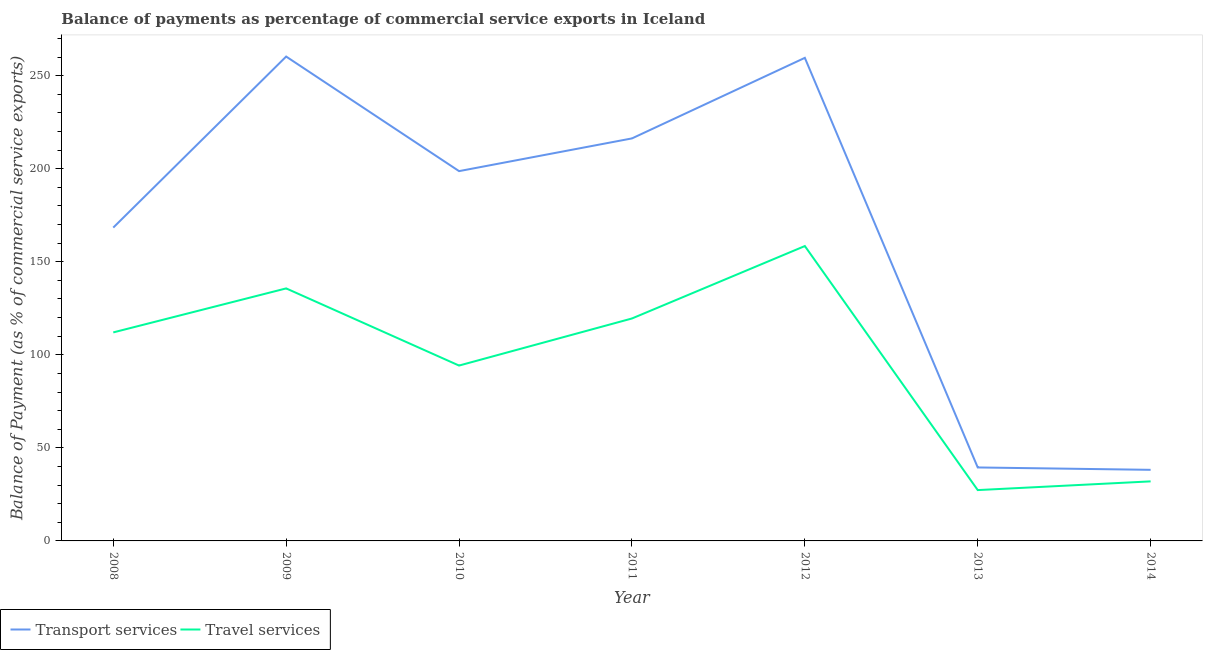What is the balance of payments of transport services in 2008?
Make the answer very short. 168.36. Across all years, what is the maximum balance of payments of travel services?
Ensure brevity in your answer.  158.45. Across all years, what is the minimum balance of payments of travel services?
Offer a terse response. 27.32. What is the total balance of payments of transport services in the graph?
Offer a very short reply. 1180.86. What is the difference between the balance of payments of travel services in 2008 and that in 2009?
Offer a very short reply. -23.64. What is the difference between the balance of payments of transport services in 2010 and the balance of payments of travel services in 2009?
Provide a short and direct response. 63.02. What is the average balance of payments of travel services per year?
Provide a succinct answer. 97.03. In the year 2013, what is the difference between the balance of payments of travel services and balance of payments of transport services?
Provide a succinct answer. -12.16. In how many years, is the balance of payments of travel services greater than 10 %?
Provide a succinct answer. 7. What is the ratio of the balance of payments of travel services in 2009 to that in 2011?
Provide a succinct answer. 1.14. Is the difference between the balance of payments of travel services in 2009 and 2013 greater than the difference between the balance of payments of transport services in 2009 and 2013?
Offer a very short reply. No. What is the difference between the highest and the second highest balance of payments of transport services?
Offer a terse response. 0.7. What is the difference between the highest and the lowest balance of payments of travel services?
Give a very brief answer. 131.13. How many lines are there?
Your response must be concise. 2. How many years are there in the graph?
Provide a succinct answer. 7. What is the difference between two consecutive major ticks on the Y-axis?
Make the answer very short. 50. Does the graph contain any zero values?
Ensure brevity in your answer.  No. Does the graph contain grids?
Your answer should be very brief. No. Where does the legend appear in the graph?
Offer a very short reply. Bottom left. How many legend labels are there?
Keep it short and to the point. 2. What is the title of the graph?
Your answer should be compact. Balance of payments as percentage of commercial service exports in Iceland. Does "IMF nonconcessional" appear as one of the legend labels in the graph?
Ensure brevity in your answer.  No. What is the label or title of the Y-axis?
Provide a succinct answer. Balance of Payment (as % of commercial service exports). What is the Balance of Payment (as % of commercial service exports) in Transport services in 2008?
Offer a terse response. 168.36. What is the Balance of Payment (as % of commercial service exports) in Travel services in 2008?
Your answer should be very brief. 112.04. What is the Balance of Payment (as % of commercial service exports) of Transport services in 2009?
Offer a very short reply. 260.27. What is the Balance of Payment (as % of commercial service exports) in Travel services in 2009?
Offer a very short reply. 135.69. What is the Balance of Payment (as % of commercial service exports) in Transport services in 2010?
Offer a terse response. 198.71. What is the Balance of Payment (as % of commercial service exports) of Travel services in 2010?
Give a very brief answer. 94.23. What is the Balance of Payment (as % of commercial service exports) in Transport services in 2011?
Offer a very short reply. 216.28. What is the Balance of Payment (as % of commercial service exports) of Travel services in 2011?
Provide a succinct answer. 119.52. What is the Balance of Payment (as % of commercial service exports) in Transport services in 2012?
Provide a short and direct response. 259.57. What is the Balance of Payment (as % of commercial service exports) of Travel services in 2012?
Keep it short and to the point. 158.45. What is the Balance of Payment (as % of commercial service exports) in Transport services in 2013?
Your answer should be very brief. 39.47. What is the Balance of Payment (as % of commercial service exports) of Travel services in 2013?
Give a very brief answer. 27.32. What is the Balance of Payment (as % of commercial service exports) in Transport services in 2014?
Offer a terse response. 38.2. What is the Balance of Payment (as % of commercial service exports) of Travel services in 2014?
Offer a terse response. 32. Across all years, what is the maximum Balance of Payment (as % of commercial service exports) of Transport services?
Your answer should be compact. 260.27. Across all years, what is the maximum Balance of Payment (as % of commercial service exports) of Travel services?
Keep it short and to the point. 158.45. Across all years, what is the minimum Balance of Payment (as % of commercial service exports) in Transport services?
Your answer should be compact. 38.2. Across all years, what is the minimum Balance of Payment (as % of commercial service exports) of Travel services?
Offer a terse response. 27.32. What is the total Balance of Payment (as % of commercial service exports) of Transport services in the graph?
Your answer should be compact. 1180.86. What is the total Balance of Payment (as % of commercial service exports) in Travel services in the graph?
Keep it short and to the point. 679.24. What is the difference between the Balance of Payment (as % of commercial service exports) of Transport services in 2008 and that in 2009?
Ensure brevity in your answer.  -91.91. What is the difference between the Balance of Payment (as % of commercial service exports) in Travel services in 2008 and that in 2009?
Give a very brief answer. -23.64. What is the difference between the Balance of Payment (as % of commercial service exports) of Transport services in 2008 and that in 2010?
Make the answer very short. -30.35. What is the difference between the Balance of Payment (as % of commercial service exports) of Travel services in 2008 and that in 2010?
Provide a short and direct response. 17.82. What is the difference between the Balance of Payment (as % of commercial service exports) in Transport services in 2008 and that in 2011?
Ensure brevity in your answer.  -47.92. What is the difference between the Balance of Payment (as % of commercial service exports) in Travel services in 2008 and that in 2011?
Provide a short and direct response. -7.48. What is the difference between the Balance of Payment (as % of commercial service exports) of Transport services in 2008 and that in 2012?
Give a very brief answer. -91.21. What is the difference between the Balance of Payment (as % of commercial service exports) in Travel services in 2008 and that in 2012?
Ensure brevity in your answer.  -46.4. What is the difference between the Balance of Payment (as % of commercial service exports) of Transport services in 2008 and that in 2013?
Provide a succinct answer. 128.89. What is the difference between the Balance of Payment (as % of commercial service exports) in Travel services in 2008 and that in 2013?
Provide a succinct answer. 84.73. What is the difference between the Balance of Payment (as % of commercial service exports) of Transport services in 2008 and that in 2014?
Keep it short and to the point. 130.16. What is the difference between the Balance of Payment (as % of commercial service exports) in Travel services in 2008 and that in 2014?
Give a very brief answer. 80.05. What is the difference between the Balance of Payment (as % of commercial service exports) of Transport services in 2009 and that in 2010?
Your response must be concise. 61.56. What is the difference between the Balance of Payment (as % of commercial service exports) of Travel services in 2009 and that in 2010?
Provide a succinct answer. 41.46. What is the difference between the Balance of Payment (as % of commercial service exports) in Transport services in 2009 and that in 2011?
Provide a succinct answer. 43.99. What is the difference between the Balance of Payment (as % of commercial service exports) in Travel services in 2009 and that in 2011?
Your answer should be very brief. 16.17. What is the difference between the Balance of Payment (as % of commercial service exports) of Transport services in 2009 and that in 2012?
Ensure brevity in your answer.  0.7. What is the difference between the Balance of Payment (as % of commercial service exports) of Travel services in 2009 and that in 2012?
Keep it short and to the point. -22.76. What is the difference between the Balance of Payment (as % of commercial service exports) of Transport services in 2009 and that in 2013?
Your answer should be very brief. 220.79. What is the difference between the Balance of Payment (as % of commercial service exports) in Travel services in 2009 and that in 2013?
Provide a short and direct response. 108.37. What is the difference between the Balance of Payment (as % of commercial service exports) in Transport services in 2009 and that in 2014?
Keep it short and to the point. 222.07. What is the difference between the Balance of Payment (as % of commercial service exports) of Travel services in 2009 and that in 2014?
Give a very brief answer. 103.69. What is the difference between the Balance of Payment (as % of commercial service exports) in Transport services in 2010 and that in 2011?
Your answer should be very brief. -17.57. What is the difference between the Balance of Payment (as % of commercial service exports) in Travel services in 2010 and that in 2011?
Make the answer very short. -25.3. What is the difference between the Balance of Payment (as % of commercial service exports) in Transport services in 2010 and that in 2012?
Your answer should be compact. -60.86. What is the difference between the Balance of Payment (as % of commercial service exports) in Travel services in 2010 and that in 2012?
Your answer should be very brief. -64.22. What is the difference between the Balance of Payment (as % of commercial service exports) in Transport services in 2010 and that in 2013?
Your answer should be very brief. 159.23. What is the difference between the Balance of Payment (as % of commercial service exports) in Travel services in 2010 and that in 2013?
Provide a short and direct response. 66.91. What is the difference between the Balance of Payment (as % of commercial service exports) in Transport services in 2010 and that in 2014?
Your answer should be compact. 160.51. What is the difference between the Balance of Payment (as % of commercial service exports) of Travel services in 2010 and that in 2014?
Keep it short and to the point. 62.23. What is the difference between the Balance of Payment (as % of commercial service exports) of Transport services in 2011 and that in 2012?
Offer a very short reply. -43.29. What is the difference between the Balance of Payment (as % of commercial service exports) of Travel services in 2011 and that in 2012?
Provide a short and direct response. -38.93. What is the difference between the Balance of Payment (as % of commercial service exports) in Transport services in 2011 and that in 2013?
Offer a terse response. 176.81. What is the difference between the Balance of Payment (as % of commercial service exports) of Travel services in 2011 and that in 2013?
Make the answer very short. 92.21. What is the difference between the Balance of Payment (as % of commercial service exports) in Transport services in 2011 and that in 2014?
Give a very brief answer. 178.08. What is the difference between the Balance of Payment (as % of commercial service exports) in Travel services in 2011 and that in 2014?
Provide a succinct answer. 87.53. What is the difference between the Balance of Payment (as % of commercial service exports) of Transport services in 2012 and that in 2013?
Give a very brief answer. 220.1. What is the difference between the Balance of Payment (as % of commercial service exports) of Travel services in 2012 and that in 2013?
Your response must be concise. 131.13. What is the difference between the Balance of Payment (as % of commercial service exports) in Transport services in 2012 and that in 2014?
Give a very brief answer. 221.37. What is the difference between the Balance of Payment (as % of commercial service exports) in Travel services in 2012 and that in 2014?
Offer a very short reply. 126.45. What is the difference between the Balance of Payment (as % of commercial service exports) of Transport services in 2013 and that in 2014?
Provide a short and direct response. 1.28. What is the difference between the Balance of Payment (as % of commercial service exports) of Travel services in 2013 and that in 2014?
Keep it short and to the point. -4.68. What is the difference between the Balance of Payment (as % of commercial service exports) in Transport services in 2008 and the Balance of Payment (as % of commercial service exports) in Travel services in 2009?
Your answer should be very brief. 32.67. What is the difference between the Balance of Payment (as % of commercial service exports) in Transport services in 2008 and the Balance of Payment (as % of commercial service exports) in Travel services in 2010?
Ensure brevity in your answer.  74.13. What is the difference between the Balance of Payment (as % of commercial service exports) in Transport services in 2008 and the Balance of Payment (as % of commercial service exports) in Travel services in 2011?
Ensure brevity in your answer.  48.84. What is the difference between the Balance of Payment (as % of commercial service exports) of Transport services in 2008 and the Balance of Payment (as % of commercial service exports) of Travel services in 2012?
Give a very brief answer. 9.91. What is the difference between the Balance of Payment (as % of commercial service exports) in Transport services in 2008 and the Balance of Payment (as % of commercial service exports) in Travel services in 2013?
Make the answer very short. 141.04. What is the difference between the Balance of Payment (as % of commercial service exports) in Transport services in 2008 and the Balance of Payment (as % of commercial service exports) in Travel services in 2014?
Offer a very short reply. 136.37. What is the difference between the Balance of Payment (as % of commercial service exports) in Transport services in 2009 and the Balance of Payment (as % of commercial service exports) in Travel services in 2010?
Your response must be concise. 166.04. What is the difference between the Balance of Payment (as % of commercial service exports) in Transport services in 2009 and the Balance of Payment (as % of commercial service exports) in Travel services in 2011?
Provide a short and direct response. 140.75. What is the difference between the Balance of Payment (as % of commercial service exports) of Transport services in 2009 and the Balance of Payment (as % of commercial service exports) of Travel services in 2012?
Your response must be concise. 101.82. What is the difference between the Balance of Payment (as % of commercial service exports) in Transport services in 2009 and the Balance of Payment (as % of commercial service exports) in Travel services in 2013?
Your answer should be compact. 232.95. What is the difference between the Balance of Payment (as % of commercial service exports) of Transport services in 2009 and the Balance of Payment (as % of commercial service exports) of Travel services in 2014?
Provide a succinct answer. 228.27. What is the difference between the Balance of Payment (as % of commercial service exports) in Transport services in 2010 and the Balance of Payment (as % of commercial service exports) in Travel services in 2011?
Keep it short and to the point. 79.19. What is the difference between the Balance of Payment (as % of commercial service exports) of Transport services in 2010 and the Balance of Payment (as % of commercial service exports) of Travel services in 2012?
Your answer should be very brief. 40.26. What is the difference between the Balance of Payment (as % of commercial service exports) in Transport services in 2010 and the Balance of Payment (as % of commercial service exports) in Travel services in 2013?
Provide a succinct answer. 171.39. What is the difference between the Balance of Payment (as % of commercial service exports) in Transport services in 2010 and the Balance of Payment (as % of commercial service exports) in Travel services in 2014?
Give a very brief answer. 166.71. What is the difference between the Balance of Payment (as % of commercial service exports) in Transport services in 2011 and the Balance of Payment (as % of commercial service exports) in Travel services in 2012?
Ensure brevity in your answer.  57.83. What is the difference between the Balance of Payment (as % of commercial service exports) of Transport services in 2011 and the Balance of Payment (as % of commercial service exports) of Travel services in 2013?
Keep it short and to the point. 188.97. What is the difference between the Balance of Payment (as % of commercial service exports) in Transport services in 2011 and the Balance of Payment (as % of commercial service exports) in Travel services in 2014?
Provide a short and direct response. 184.29. What is the difference between the Balance of Payment (as % of commercial service exports) of Transport services in 2012 and the Balance of Payment (as % of commercial service exports) of Travel services in 2013?
Give a very brief answer. 232.26. What is the difference between the Balance of Payment (as % of commercial service exports) in Transport services in 2012 and the Balance of Payment (as % of commercial service exports) in Travel services in 2014?
Offer a very short reply. 227.58. What is the difference between the Balance of Payment (as % of commercial service exports) in Transport services in 2013 and the Balance of Payment (as % of commercial service exports) in Travel services in 2014?
Make the answer very short. 7.48. What is the average Balance of Payment (as % of commercial service exports) in Transport services per year?
Your response must be concise. 168.69. What is the average Balance of Payment (as % of commercial service exports) in Travel services per year?
Offer a terse response. 97.03. In the year 2008, what is the difference between the Balance of Payment (as % of commercial service exports) of Transport services and Balance of Payment (as % of commercial service exports) of Travel services?
Offer a terse response. 56.32. In the year 2009, what is the difference between the Balance of Payment (as % of commercial service exports) in Transport services and Balance of Payment (as % of commercial service exports) in Travel services?
Make the answer very short. 124.58. In the year 2010, what is the difference between the Balance of Payment (as % of commercial service exports) in Transport services and Balance of Payment (as % of commercial service exports) in Travel services?
Offer a terse response. 104.48. In the year 2011, what is the difference between the Balance of Payment (as % of commercial service exports) in Transport services and Balance of Payment (as % of commercial service exports) in Travel services?
Provide a succinct answer. 96.76. In the year 2012, what is the difference between the Balance of Payment (as % of commercial service exports) of Transport services and Balance of Payment (as % of commercial service exports) of Travel services?
Give a very brief answer. 101.12. In the year 2013, what is the difference between the Balance of Payment (as % of commercial service exports) in Transport services and Balance of Payment (as % of commercial service exports) in Travel services?
Ensure brevity in your answer.  12.16. In the year 2014, what is the difference between the Balance of Payment (as % of commercial service exports) in Transport services and Balance of Payment (as % of commercial service exports) in Travel services?
Your answer should be compact. 6.2. What is the ratio of the Balance of Payment (as % of commercial service exports) of Transport services in 2008 to that in 2009?
Keep it short and to the point. 0.65. What is the ratio of the Balance of Payment (as % of commercial service exports) of Travel services in 2008 to that in 2009?
Keep it short and to the point. 0.83. What is the ratio of the Balance of Payment (as % of commercial service exports) in Transport services in 2008 to that in 2010?
Ensure brevity in your answer.  0.85. What is the ratio of the Balance of Payment (as % of commercial service exports) of Travel services in 2008 to that in 2010?
Your response must be concise. 1.19. What is the ratio of the Balance of Payment (as % of commercial service exports) in Transport services in 2008 to that in 2011?
Make the answer very short. 0.78. What is the ratio of the Balance of Payment (as % of commercial service exports) of Travel services in 2008 to that in 2011?
Your answer should be compact. 0.94. What is the ratio of the Balance of Payment (as % of commercial service exports) in Transport services in 2008 to that in 2012?
Ensure brevity in your answer.  0.65. What is the ratio of the Balance of Payment (as % of commercial service exports) in Travel services in 2008 to that in 2012?
Ensure brevity in your answer.  0.71. What is the ratio of the Balance of Payment (as % of commercial service exports) in Transport services in 2008 to that in 2013?
Provide a short and direct response. 4.27. What is the ratio of the Balance of Payment (as % of commercial service exports) in Travel services in 2008 to that in 2013?
Keep it short and to the point. 4.1. What is the ratio of the Balance of Payment (as % of commercial service exports) in Transport services in 2008 to that in 2014?
Offer a very short reply. 4.41. What is the ratio of the Balance of Payment (as % of commercial service exports) in Travel services in 2008 to that in 2014?
Your answer should be very brief. 3.5. What is the ratio of the Balance of Payment (as % of commercial service exports) in Transport services in 2009 to that in 2010?
Your answer should be very brief. 1.31. What is the ratio of the Balance of Payment (as % of commercial service exports) of Travel services in 2009 to that in 2010?
Make the answer very short. 1.44. What is the ratio of the Balance of Payment (as % of commercial service exports) of Transport services in 2009 to that in 2011?
Make the answer very short. 1.2. What is the ratio of the Balance of Payment (as % of commercial service exports) in Travel services in 2009 to that in 2011?
Make the answer very short. 1.14. What is the ratio of the Balance of Payment (as % of commercial service exports) in Travel services in 2009 to that in 2012?
Make the answer very short. 0.86. What is the ratio of the Balance of Payment (as % of commercial service exports) of Transport services in 2009 to that in 2013?
Offer a very short reply. 6.59. What is the ratio of the Balance of Payment (as % of commercial service exports) of Travel services in 2009 to that in 2013?
Ensure brevity in your answer.  4.97. What is the ratio of the Balance of Payment (as % of commercial service exports) of Transport services in 2009 to that in 2014?
Provide a short and direct response. 6.81. What is the ratio of the Balance of Payment (as % of commercial service exports) in Travel services in 2009 to that in 2014?
Make the answer very short. 4.24. What is the ratio of the Balance of Payment (as % of commercial service exports) in Transport services in 2010 to that in 2011?
Make the answer very short. 0.92. What is the ratio of the Balance of Payment (as % of commercial service exports) in Travel services in 2010 to that in 2011?
Provide a short and direct response. 0.79. What is the ratio of the Balance of Payment (as % of commercial service exports) in Transport services in 2010 to that in 2012?
Ensure brevity in your answer.  0.77. What is the ratio of the Balance of Payment (as % of commercial service exports) in Travel services in 2010 to that in 2012?
Make the answer very short. 0.59. What is the ratio of the Balance of Payment (as % of commercial service exports) in Transport services in 2010 to that in 2013?
Offer a terse response. 5.03. What is the ratio of the Balance of Payment (as % of commercial service exports) in Travel services in 2010 to that in 2013?
Make the answer very short. 3.45. What is the ratio of the Balance of Payment (as % of commercial service exports) in Transport services in 2010 to that in 2014?
Your answer should be very brief. 5.2. What is the ratio of the Balance of Payment (as % of commercial service exports) in Travel services in 2010 to that in 2014?
Your answer should be very brief. 2.94. What is the ratio of the Balance of Payment (as % of commercial service exports) of Transport services in 2011 to that in 2012?
Make the answer very short. 0.83. What is the ratio of the Balance of Payment (as % of commercial service exports) in Travel services in 2011 to that in 2012?
Keep it short and to the point. 0.75. What is the ratio of the Balance of Payment (as % of commercial service exports) of Transport services in 2011 to that in 2013?
Keep it short and to the point. 5.48. What is the ratio of the Balance of Payment (as % of commercial service exports) in Travel services in 2011 to that in 2013?
Your answer should be compact. 4.38. What is the ratio of the Balance of Payment (as % of commercial service exports) in Transport services in 2011 to that in 2014?
Offer a very short reply. 5.66. What is the ratio of the Balance of Payment (as % of commercial service exports) in Travel services in 2011 to that in 2014?
Provide a succinct answer. 3.74. What is the ratio of the Balance of Payment (as % of commercial service exports) of Transport services in 2012 to that in 2013?
Your answer should be compact. 6.58. What is the ratio of the Balance of Payment (as % of commercial service exports) of Travel services in 2012 to that in 2013?
Offer a very short reply. 5.8. What is the ratio of the Balance of Payment (as % of commercial service exports) in Transport services in 2012 to that in 2014?
Your response must be concise. 6.8. What is the ratio of the Balance of Payment (as % of commercial service exports) in Travel services in 2012 to that in 2014?
Provide a short and direct response. 4.95. What is the ratio of the Balance of Payment (as % of commercial service exports) of Transport services in 2013 to that in 2014?
Ensure brevity in your answer.  1.03. What is the ratio of the Balance of Payment (as % of commercial service exports) in Travel services in 2013 to that in 2014?
Offer a terse response. 0.85. What is the difference between the highest and the second highest Balance of Payment (as % of commercial service exports) of Transport services?
Provide a succinct answer. 0.7. What is the difference between the highest and the second highest Balance of Payment (as % of commercial service exports) in Travel services?
Your response must be concise. 22.76. What is the difference between the highest and the lowest Balance of Payment (as % of commercial service exports) of Transport services?
Make the answer very short. 222.07. What is the difference between the highest and the lowest Balance of Payment (as % of commercial service exports) in Travel services?
Offer a terse response. 131.13. 